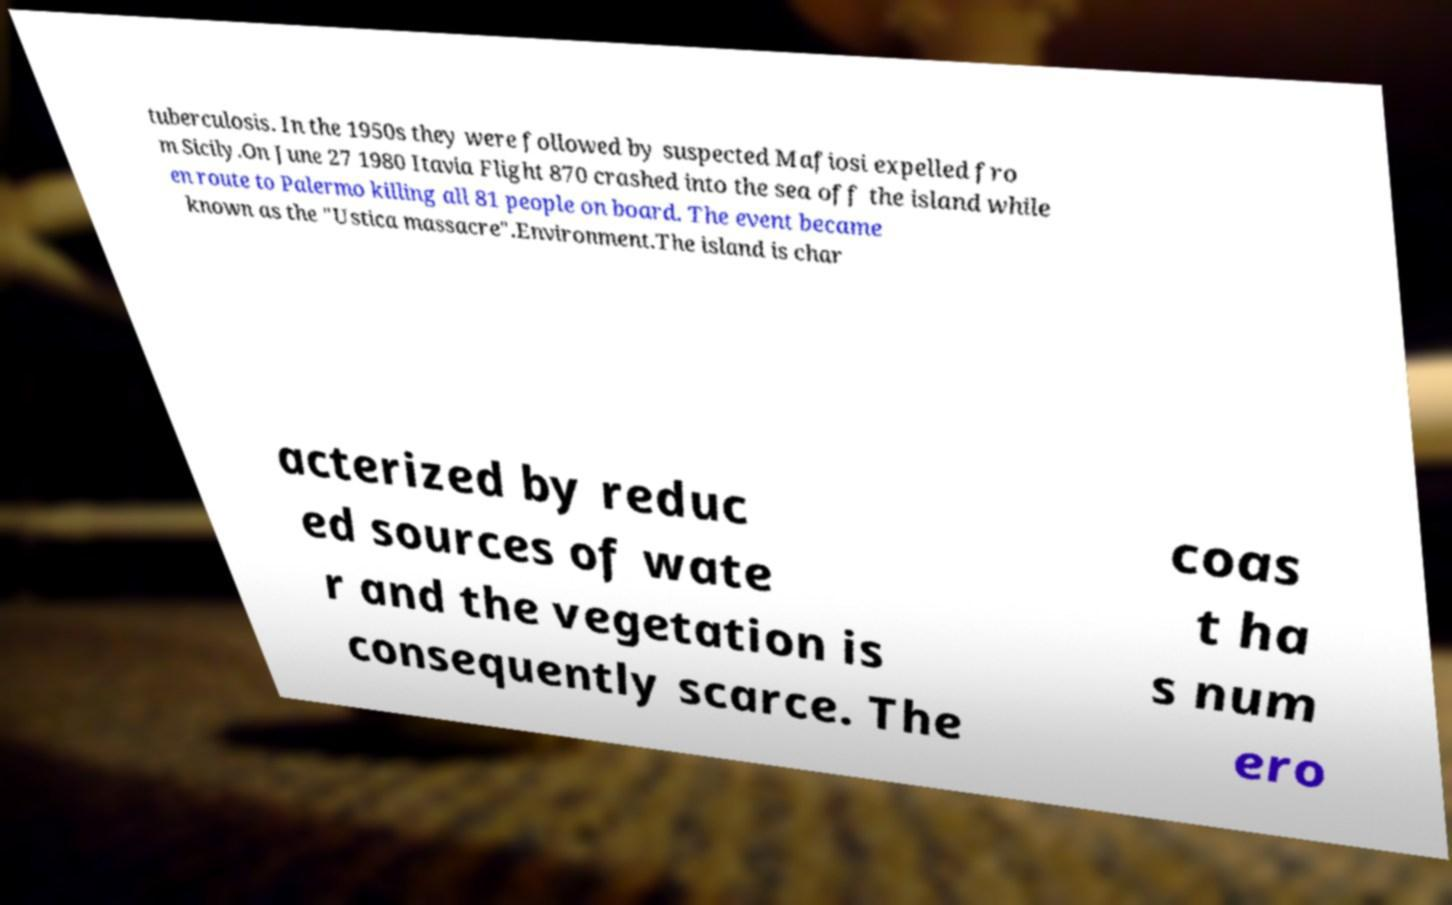Can you read and provide the text displayed in the image?This photo seems to have some interesting text. Can you extract and type it out for me? tuberculosis. In the 1950s they were followed by suspected Mafiosi expelled fro m Sicily.On June 27 1980 Itavia Flight 870 crashed into the sea off the island while en route to Palermo killing all 81 people on board. The event became known as the "Ustica massacre".Environment.The island is char acterized by reduc ed sources of wate r and the vegetation is consequently scarce. The coas t ha s num ero 